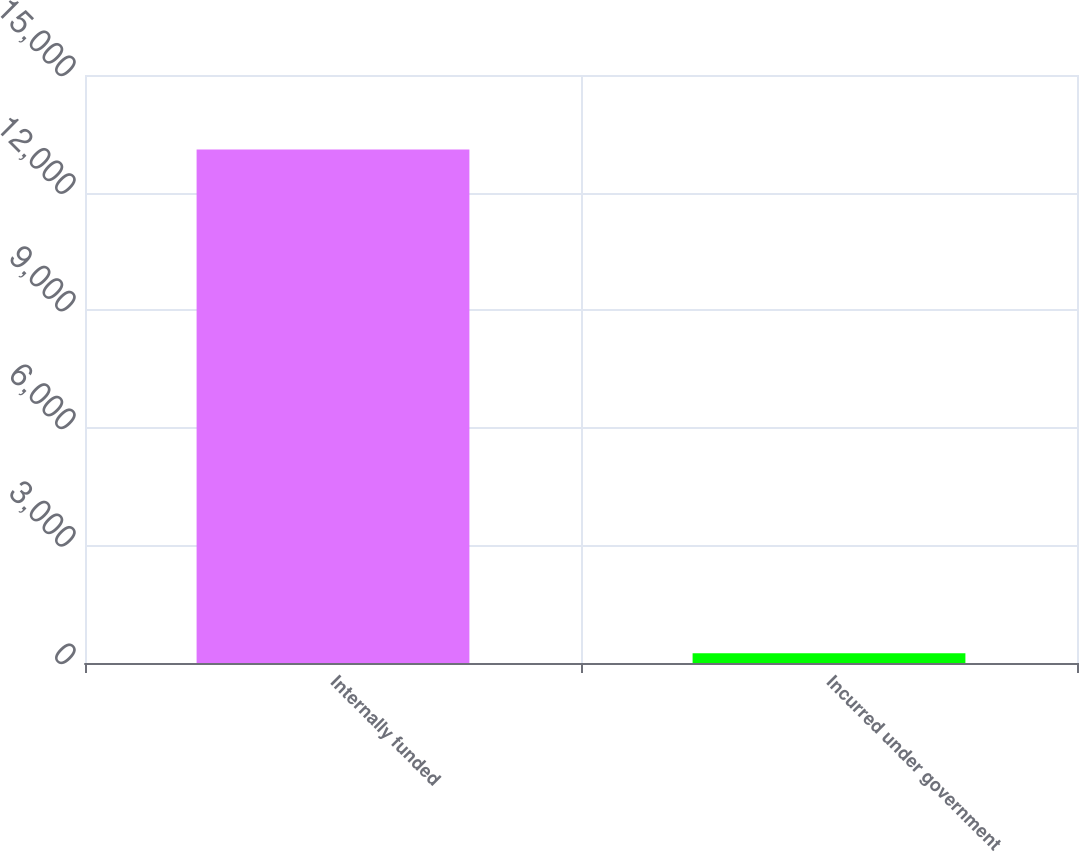Convert chart to OTSL. <chart><loc_0><loc_0><loc_500><loc_500><bar_chart><fcel>Internally funded<fcel>Incurred under government<nl><fcel>13100<fcel>250<nl></chart> 